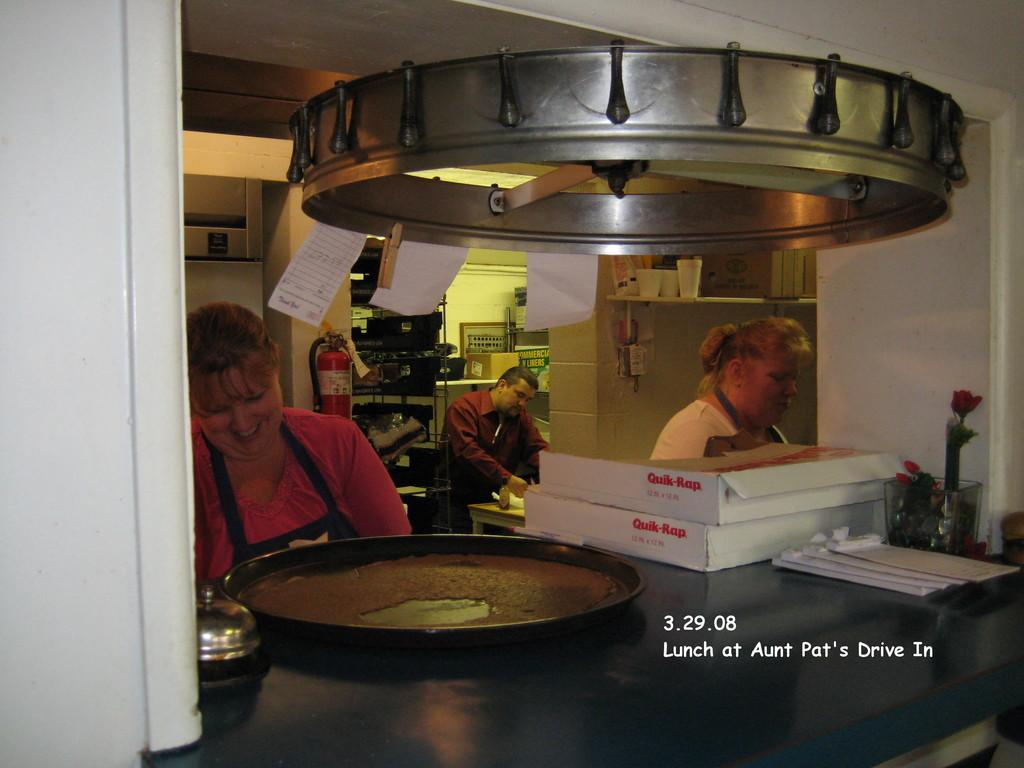<image>
Offer a succinct explanation of the picture presented. Three people are making pizzas and two pizza boxes say Quik-Rap on it 